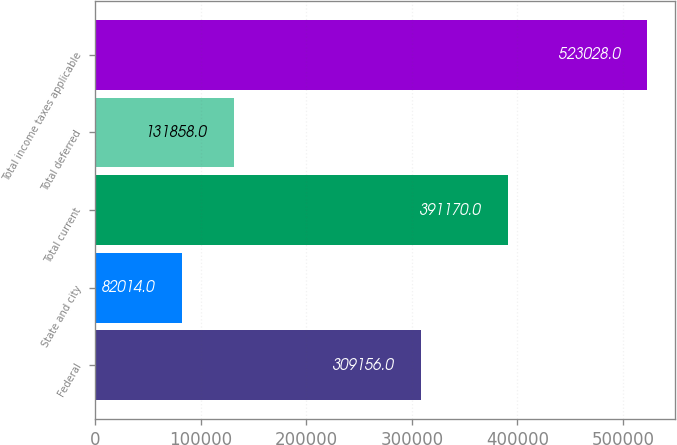Convert chart to OTSL. <chart><loc_0><loc_0><loc_500><loc_500><bar_chart><fcel>Federal<fcel>State and city<fcel>Total current<fcel>Total deferred<fcel>Total income taxes applicable<nl><fcel>309156<fcel>82014<fcel>391170<fcel>131858<fcel>523028<nl></chart> 